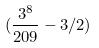Convert formula to latex. <formula><loc_0><loc_0><loc_500><loc_500>( \frac { 3 ^ { 8 } } { 2 0 9 } - 3 / 2 )</formula> 